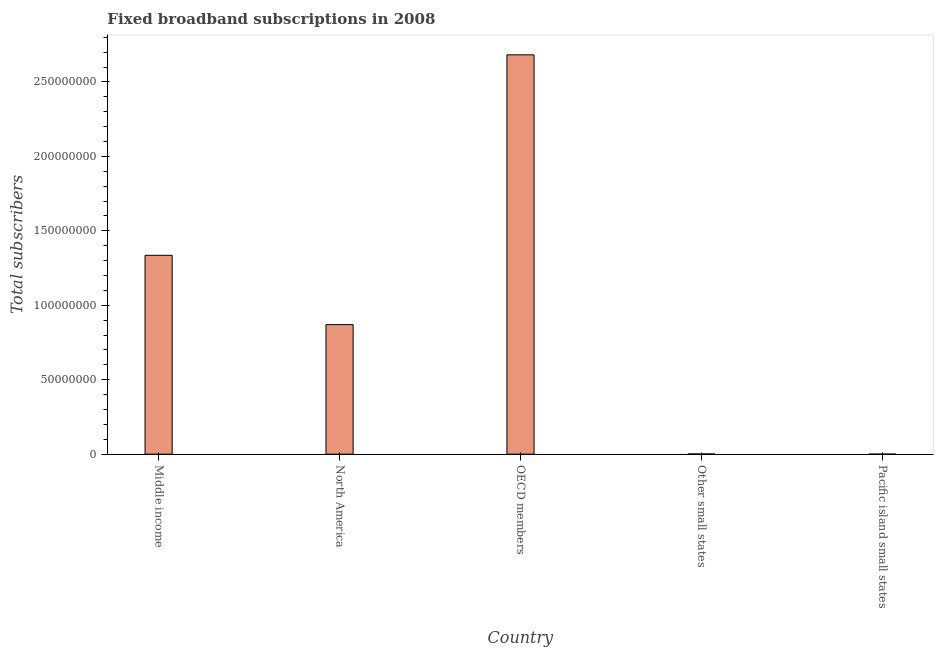Does the graph contain any zero values?
Offer a very short reply. No. What is the title of the graph?
Offer a terse response. Fixed broadband subscriptions in 2008. What is the label or title of the Y-axis?
Give a very brief answer. Total subscribers. What is the total number of fixed broadband subscriptions in Pacific island small states?
Make the answer very short. 1.67e+04. Across all countries, what is the maximum total number of fixed broadband subscriptions?
Give a very brief answer. 2.68e+08. Across all countries, what is the minimum total number of fixed broadband subscriptions?
Offer a very short reply. 1.67e+04. In which country was the total number of fixed broadband subscriptions minimum?
Your answer should be compact. Pacific island small states. What is the sum of the total number of fixed broadband subscriptions?
Provide a short and direct response. 4.89e+08. What is the difference between the total number of fixed broadband subscriptions in North America and Pacific island small states?
Your answer should be compact. 8.70e+07. What is the average total number of fixed broadband subscriptions per country?
Give a very brief answer. 9.78e+07. What is the median total number of fixed broadband subscriptions?
Your response must be concise. 8.70e+07. What is the ratio of the total number of fixed broadband subscriptions in OECD members to that in Other small states?
Your response must be concise. 1968.5. What is the difference between the highest and the second highest total number of fixed broadband subscriptions?
Your answer should be compact. 1.35e+08. Is the sum of the total number of fixed broadband subscriptions in Middle income and Other small states greater than the maximum total number of fixed broadband subscriptions across all countries?
Provide a succinct answer. No. What is the difference between the highest and the lowest total number of fixed broadband subscriptions?
Ensure brevity in your answer.  2.68e+08. Are all the bars in the graph horizontal?
Give a very brief answer. No. What is the Total subscribers of Middle income?
Provide a short and direct response. 1.34e+08. What is the Total subscribers of North America?
Give a very brief answer. 8.70e+07. What is the Total subscribers in OECD members?
Offer a terse response. 2.68e+08. What is the Total subscribers in Other small states?
Ensure brevity in your answer.  1.36e+05. What is the Total subscribers of Pacific island small states?
Ensure brevity in your answer.  1.67e+04. What is the difference between the Total subscribers in Middle income and North America?
Offer a very short reply. 4.66e+07. What is the difference between the Total subscribers in Middle income and OECD members?
Offer a very short reply. -1.35e+08. What is the difference between the Total subscribers in Middle income and Other small states?
Provide a short and direct response. 1.33e+08. What is the difference between the Total subscribers in Middle income and Pacific island small states?
Offer a very short reply. 1.34e+08. What is the difference between the Total subscribers in North America and OECD members?
Offer a terse response. -1.81e+08. What is the difference between the Total subscribers in North America and Other small states?
Provide a succinct answer. 8.69e+07. What is the difference between the Total subscribers in North America and Pacific island small states?
Your answer should be very brief. 8.70e+07. What is the difference between the Total subscribers in OECD members and Other small states?
Offer a very short reply. 2.68e+08. What is the difference between the Total subscribers in OECD members and Pacific island small states?
Keep it short and to the point. 2.68e+08. What is the difference between the Total subscribers in Other small states and Pacific island small states?
Your answer should be very brief. 1.20e+05. What is the ratio of the Total subscribers in Middle income to that in North America?
Provide a succinct answer. 1.53. What is the ratio of the Total subscribers in Middle income to that in OECD members?
Ensure brevity in your answer.  0.5. What is the ratio of the Total subscribers in Middle income to that in Other small states?
Offer a very short reply. 980.3. What is the ratio of the Total subscribers in Middle income to that in Pacific island small states?
Provide a short and direct response. 7999.72. What is the ratio of the Total subscribers in North America to that in OECD members?
Your answer should be very brief. 0.32. What is the ratio of the Total subscribers in North America to that in Other small states?
Your answer should be compact. 638.51. What is the ratio of the Total subscribers in North America to that in Pacific island small states?
Your response must be concise. 5210.58. What is the ratio of the Total subscribers in OECD members to that in Other small states?
Offer a terse response. 1968.5. What is the ratio of the Total subscribers in OECD members to that in Pacific island small states?
Provide a succinct answer. 1.61e+04. What is the ratio of the Total subscribers in Other small states to that in Pacific island small states?
Give a very brief answer. 8.16. 